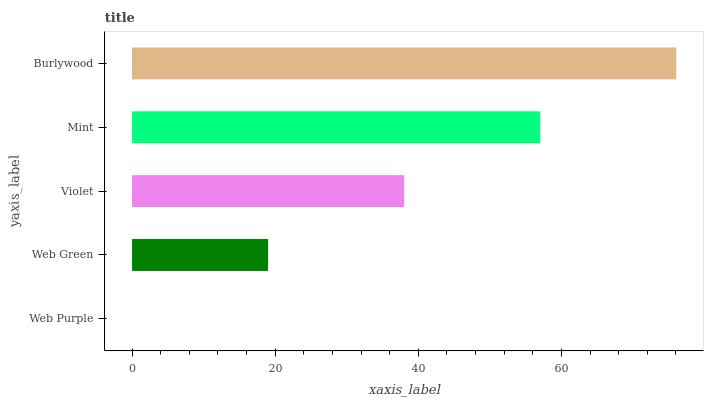Is Web Purple the minimum?
Answer yes or no. Yes. Is Burlywood the maximum?
Answer yes or no. Yes. Is Web Green the minimum?
Answer yes or no. No. Is Web Green the maximum?
Answer yes or no. No. Is Web Green greater than Web Purple?
Answer yes or no. Yes. Is Web Purple less than Web Green?
Answer yes or no. Yes. Is Web Purple greater than Web Green?
Answer yes or no. No. Is Web Green less than Web Purple?
Answer yes or no. No. Is Violet the high median?
Answer yes or no. Yes. Is Violet the low median?
Answer yes or no. Yes. Is Web Purple the high median?
Answer yes or no. No. Is Burlywood the low median?
Answer yes or no. No. 